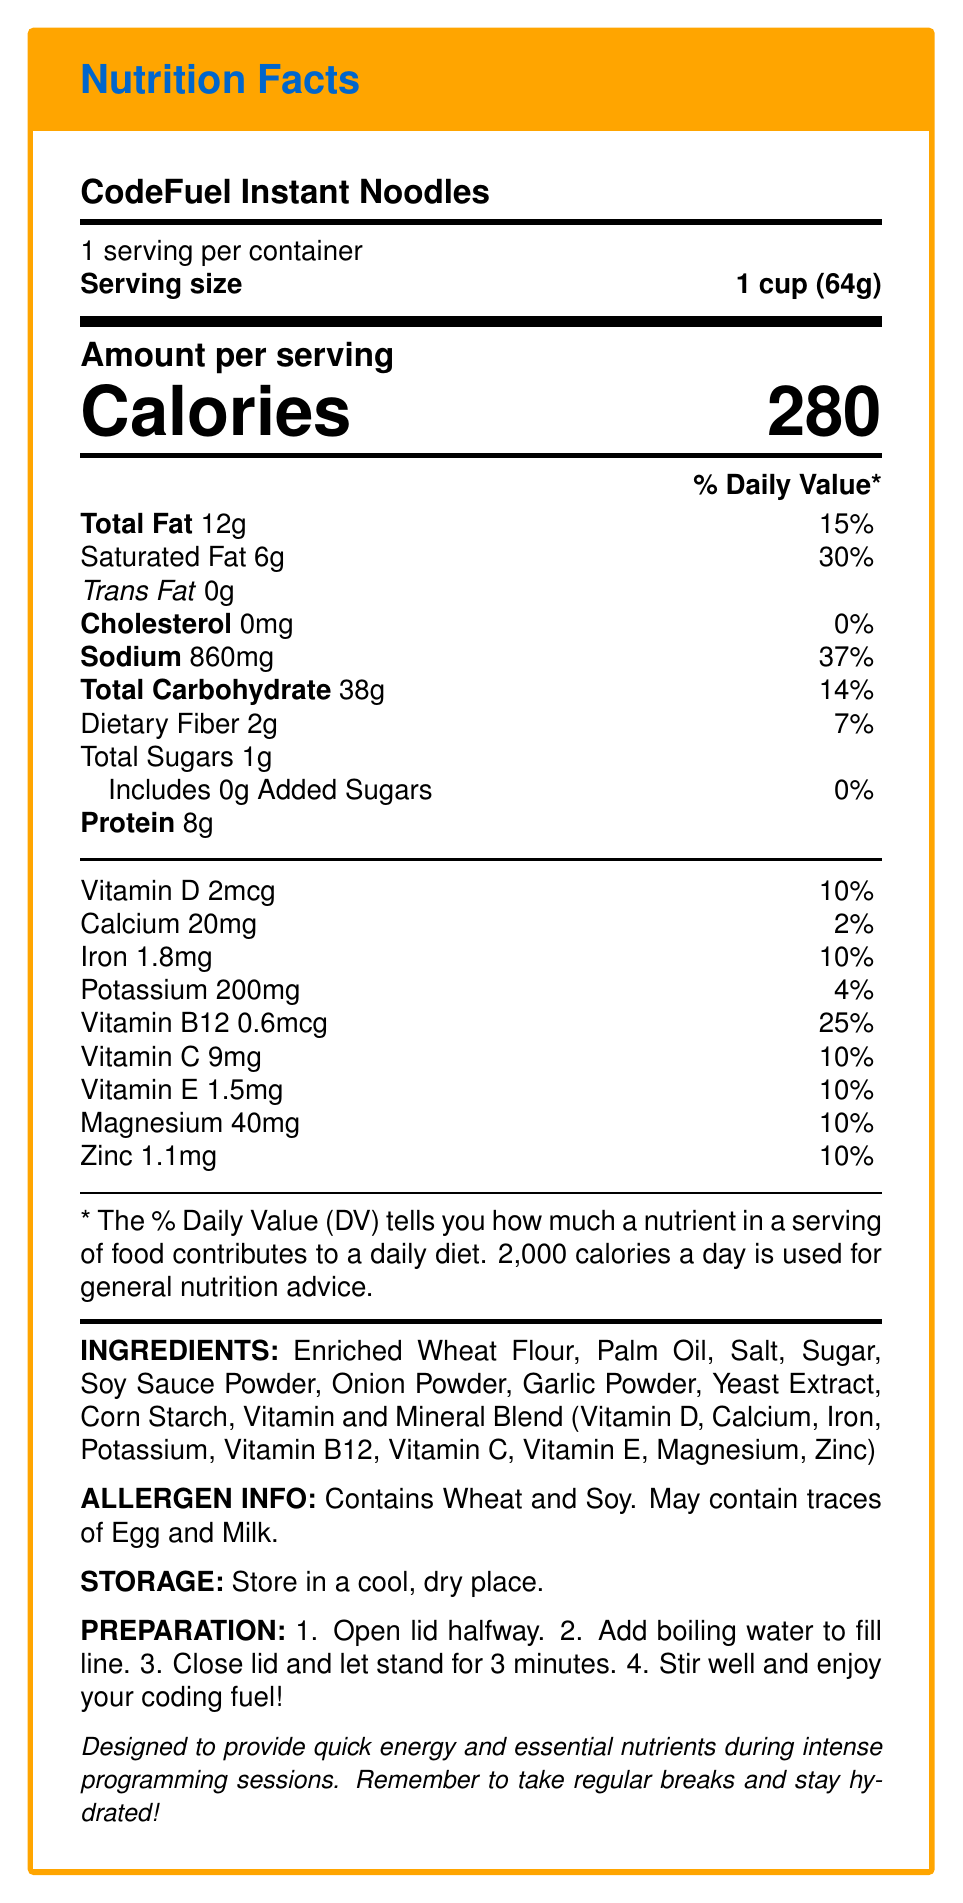What is the serving size for CodeFuel Instant Noodles? The document specifies the serving size as "1 cup (64g)" at the top of the label.
Answer: 1 cup (64g) How many calories are in one serving of CodeFuel Instant Noodles? The label indicates that there are "Calories 280" per serving.
Answer: 280 calories What percent of the daily value of saturated fat is in one serving? According to the label, saturated fat is listed as "6g" with a daily value of "30%".
Answer: 30% How much protein is in one serving of CodeFuel Instant Noodles? The document lists the protein content as "8g".
Answer: 8g What is the sodium content in a serving and its daily value percentage? The label states that the sodium content is "860mg" with a daily value of "37%".
Answer: 860mg, 37% Which vitamins and minerals are included in the Vitamin and Mineral Blend? The ingredients section lists the Vitamin and Mineral Blend contents.
Answer: Vitamin D, Calcium, Iron, Potassium, Vitamin B12, Vitamin C, Vitamin E, Magnesium, Zinc What are the potential allergens present in CodeFuel Instant Noodles? The allergen information notes that the product "Contains Wheat and Soy. May contain traces of Egg and Milk."
Answer: Wheat and Soy. May contain traces of Egg and Milk. Where should you store CodeFuel Instant Noodles? The storage instructions are to "Store in a cool, dry place."
Answer: In a cool, dry place How many grams of dietary fiber are in one serving? The label shows that dietary fiber is "2g".
Answer: 2g What is the preparation time for CodeFuel Instant Noodles? The preparation instructions on the label mention that the noodles should stand for "3 minutes" after adding boiling water.
Answer: 3 minutes Which statement is correct: A. CodeFuel Instant Noodles contain 5g of saturated fat B. There are 200mg of calcium in one serving C. Vitamin B12 contributes 10% of the daily value D. The product contains 0 grams of trans fat The document states that there are "0g" of trans fat in CodeFuel Instant Noodles.
Answer: D How many servings are in one container of CodeFuel Instant Noodles? 1. 1 serving 2. 2 servings 3. 3 servings 4. 4 servings The label clearly states "1 serving per container."
Answer: 1. 1 serving Does CodeFuel Instant Noodles contain any cholesterol? The document lists cholesterol as "0mg" with a daily value of "0%".
Answer: No Summarize the nutritional components of CodeFuel Instant Noodles. Each serving of the instant noodles offers a blend of macronutrients and essential micronutrients. The product is fortified with several vitamins and minerals and is designed to be a quick and convenient meal option. It is intended to support energy and focus during demanding activities, such as programming sprints.
Answer: CodeFuel Instant Noodles provide a convenient meal with 280 calories per serving. It contains 12g of total fat, 38g of carbohydrates, 8g of protein, and essential vitamins and minerals like Vitamin D, B12, C, E, calcium, iron, potassium, magnesium, and zinc. The high sodium content is notable at 860mg per serving. This product includes potential allergens such as wheat and soy and is designed to offer nutrition and quick energy for intense programming sessions. What percentage of the daily value of iron does one serving provide? The label specifies that one serving contains "Iron 1.8mg" which equates to "10%" of the daily value.
Answer: 10% What is the exact amount of added sugars in a serving? The document shows "Includes 0g Added Sugars."
Answer: 0g Can consuming a serving of CodeFuel Instant Noodles fulfill 100% of any nutrient's daily value? The highest percentage for any nutrient in the document is Vitamin B12 at "25%," indicating no single nutrient reaches 100% of the daily value.
Answer: No Does the product contain enriched wheat flour? The ingredients section lists "Enriched Wheat Flour."
Answer: Yes What specific advice does the developer note provide? The developer note states: "Remember to take regular breaks and stay hydrated!"
Answer: Take regular breaks and stay hydrated 